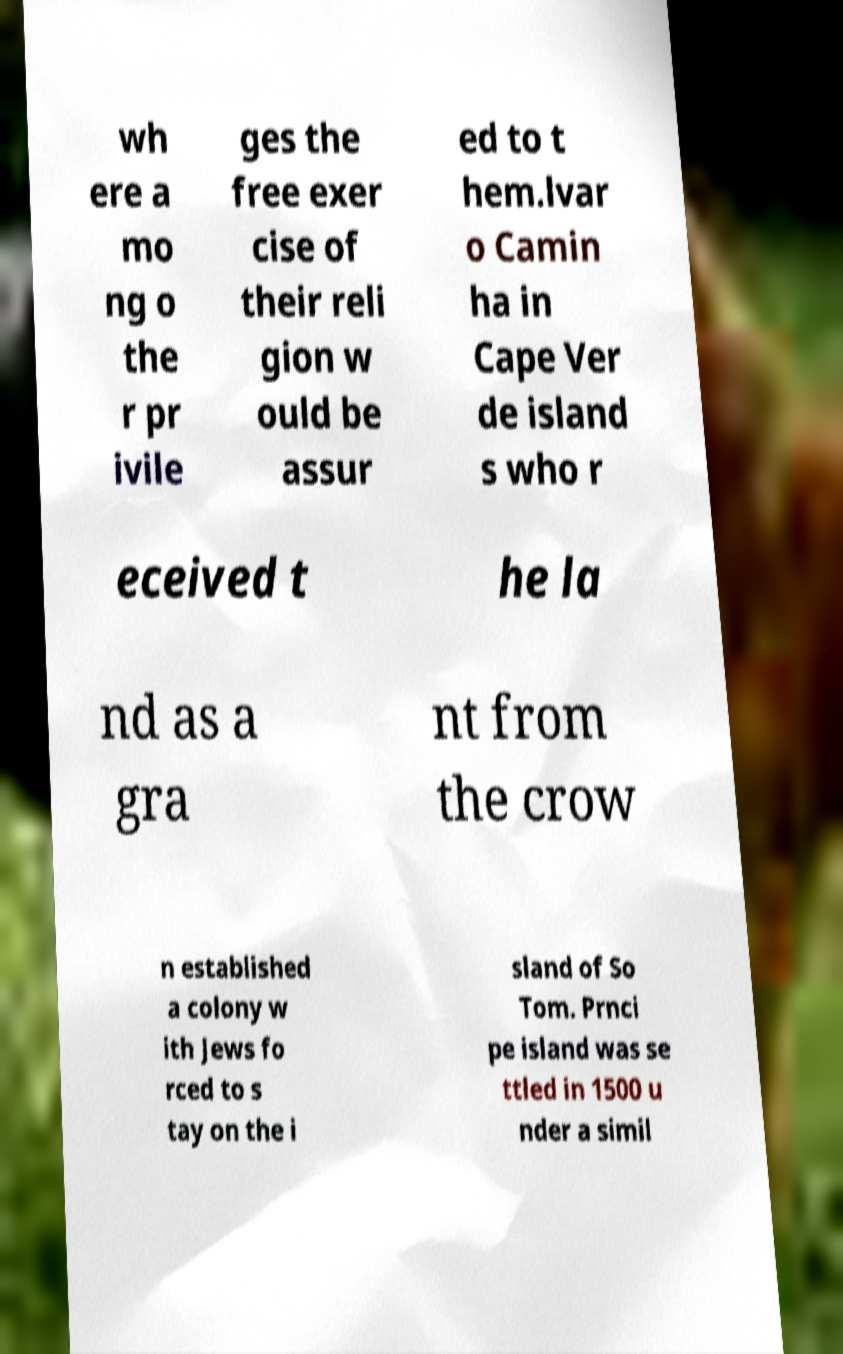Can you read and provide the text displayed in the image?This photo seems to have some interesting text. Can you extract and type it out for me? wh ere a mo ng o the r pr ivile ges the free exer cise of their reli gion w ould be assur ed to t hem.lvar o Camin ha in Cape Ver de island s who r eceived t he la nd as a gra nt from the crow n established a colony w ith Jews fo rced to s tay on the i sland of So Tom. Prnci pe island was se ttled in 1500 u nder a simil 